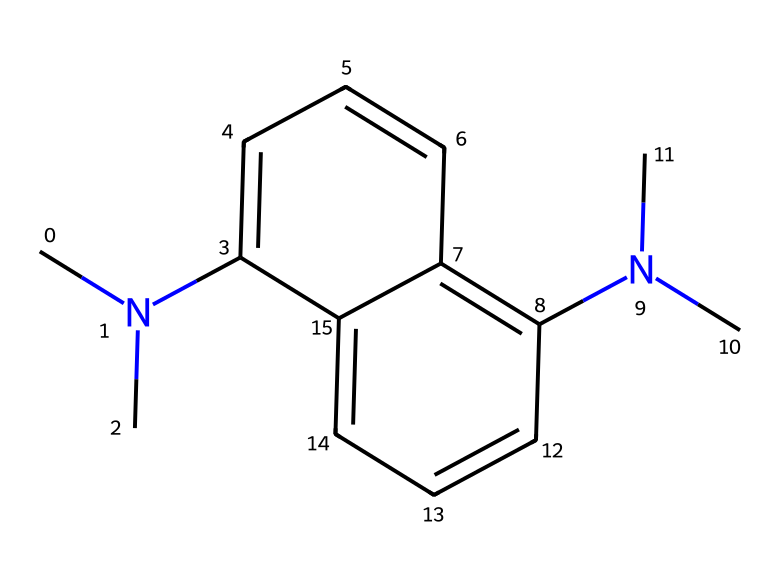What is the total number of nitrogen atoms in this molecule? The SMILES representation shows two nitrogen atoms, which are indicated by the 'N' symbols. There are no other nitrogen atoms present in the structure.
Answer: 2 How many carbon atoms are present in this chemical structure? By analyzing the SMILES representation, we can count the 'C' symbols. There are 14 carbon atoms total in this molecule, including both the aliphatic and aromatic parts of the structure.
Answer: 14 What type of chemical compound is proton sponge classified as? Proton sponge is classified as a superbase due to its ability to deprotonate weak acids and its high basicity. The presence of nitrogen atoms contributes to this classification.
Answer: superbase What functional groups are evident in the chemical structure? The structure mainly contains aromatic rings and tertiary amine functional groups, which are characterized by the nitrogen atoms bonded to three carbon atoms each.
Answer: aromatic rings and tertiary amine Does this compound likely to be soluble in water? Given its structure and the presence of nonpolar carbon chains along with polar nitrogen, this compound is expected to have moderate solubility in water, but primarily characteristics of organic solvents.
Answer: moderate solubility in water What role do the nitrogen groups play in the basicity of this compound? The nitrogen atoms in this compound provide lone pairs of electrons that can accept protons, significantly enhancing its basic character. In this case, the tertiary amines stabilize the positive charge that forms upon protonation.
Answer: enhance basicity 